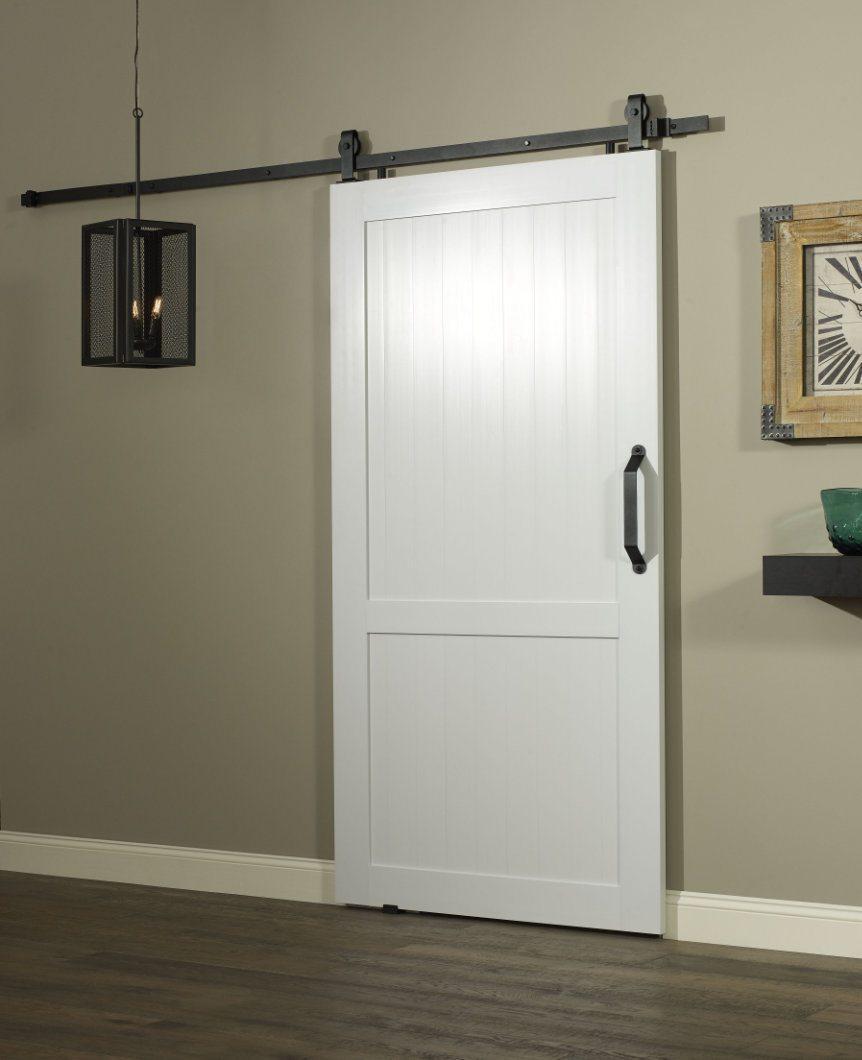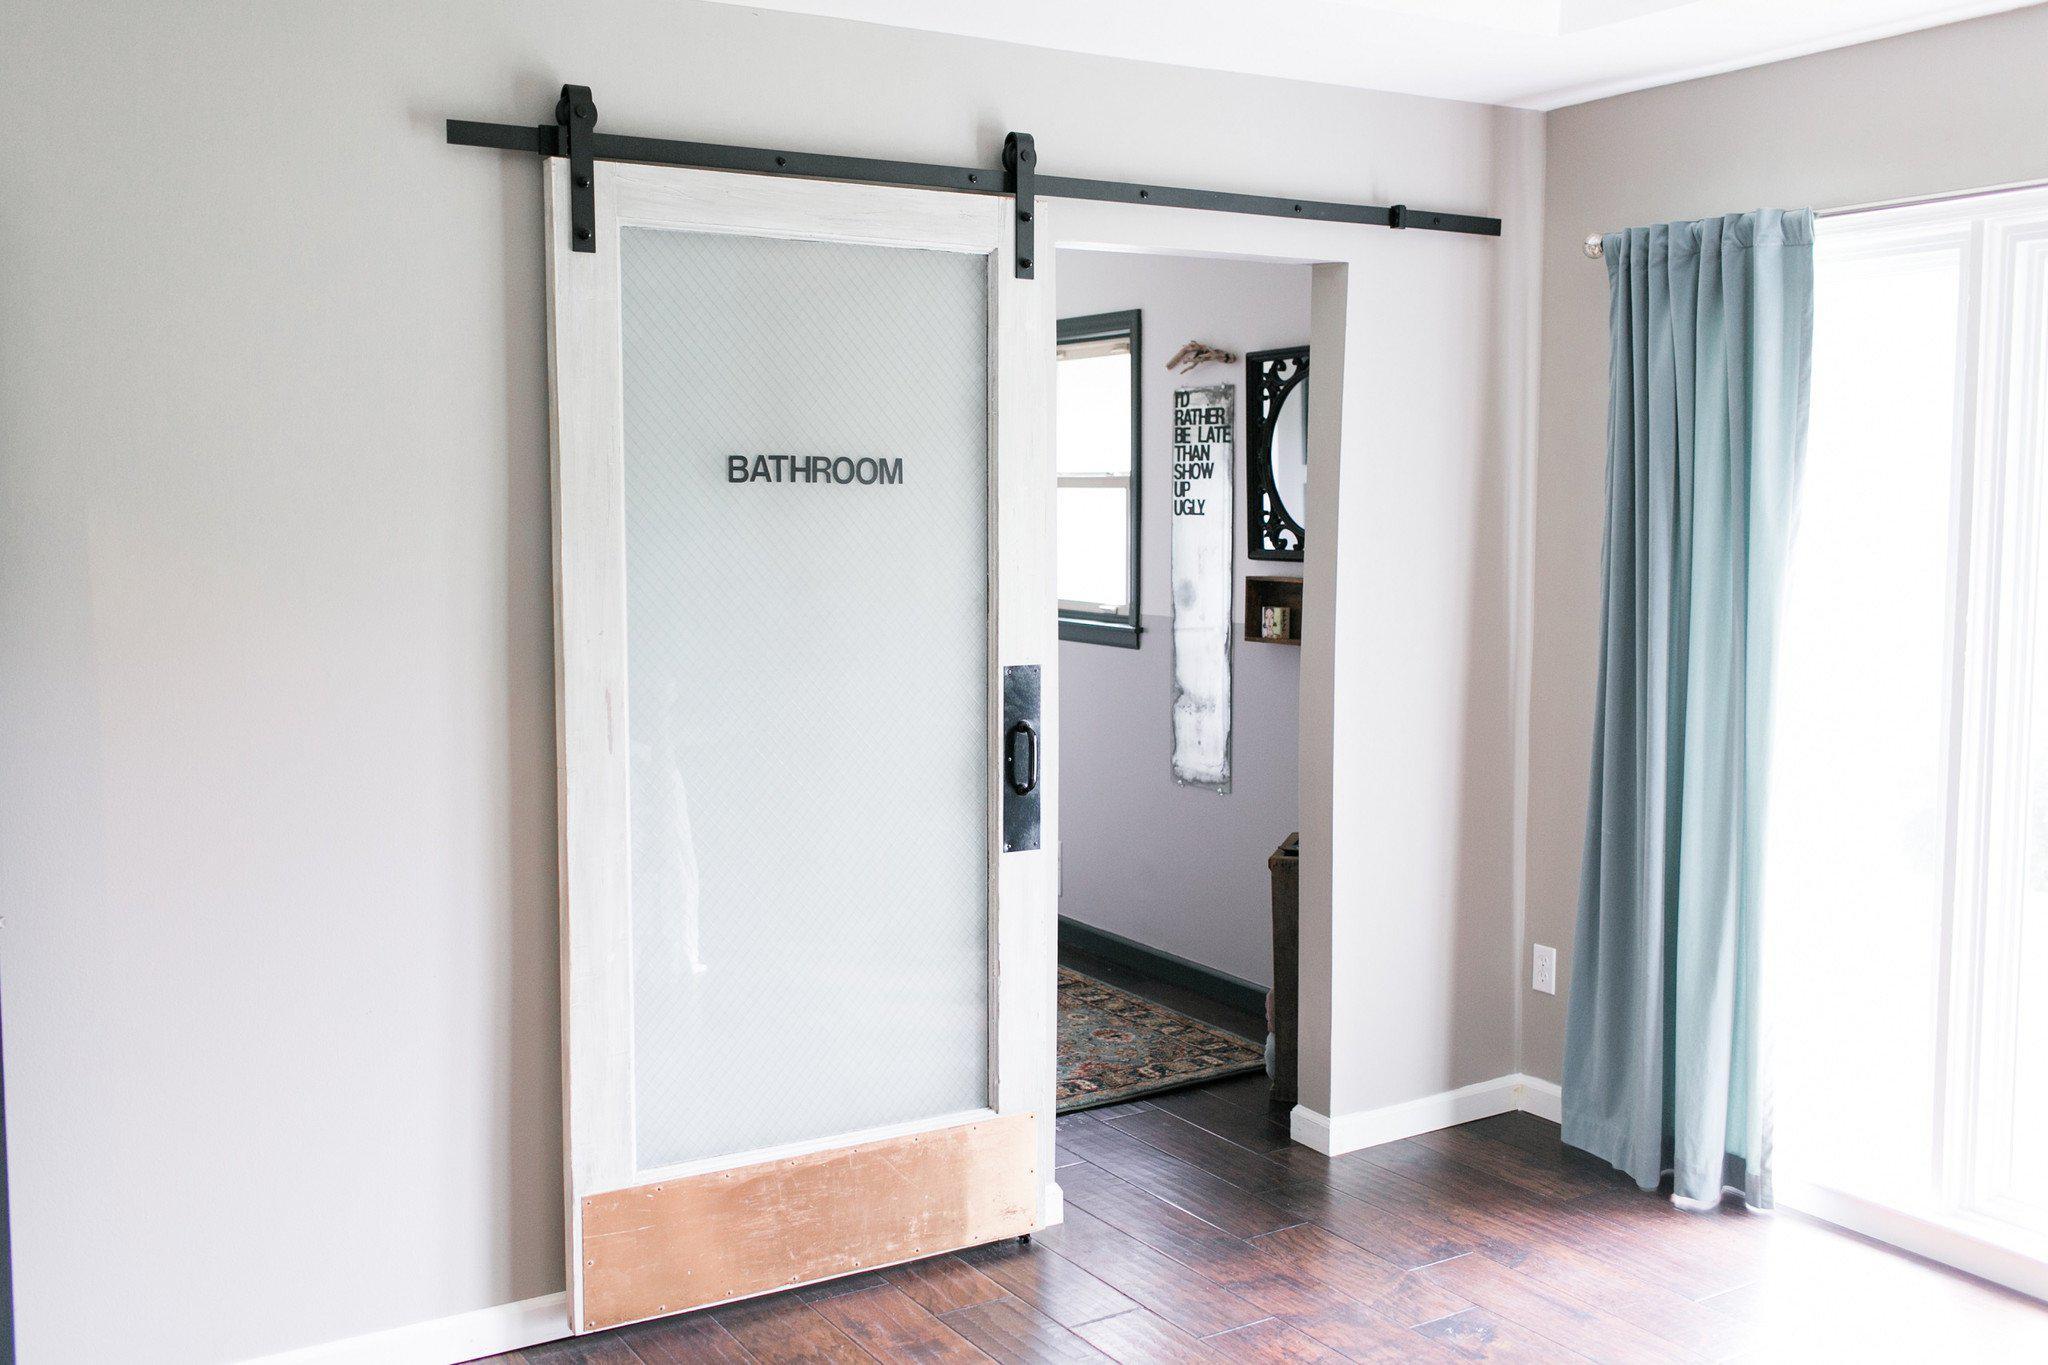The first image is the image on the left, the second image is the image on the right. Assess this claim about the two images: "There is  total of two white hanging doors.". Correct or not? Answer yes or no. Yes. The first image is the image on the left, the second image is the image on the right. Assess this claim about the two images: "A white door that slides on a black bar overhead has a brown rectangular 'kickplate' at the bottom of the open door.". Correct or not? Answer yes or no. Yes. 